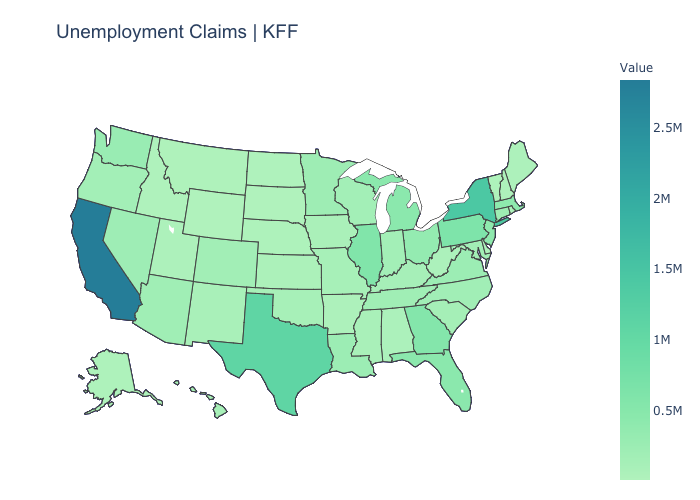Among the states that border Tennessee , does Arkansas have the lowest value?
Write a very short answer. Yes. Does Wisconsin have the lowest value in the MidWest?
Quick response, please. No. Does the map have missing data?
Be succinct. No. Does the map have missing data?
Concise answer only. No. Among the states that border Wisconsin , which have the highest value?
Keep it brief. Illinois. Does Delaware have the lowest value in the South?
Answer briefly. Yes. 